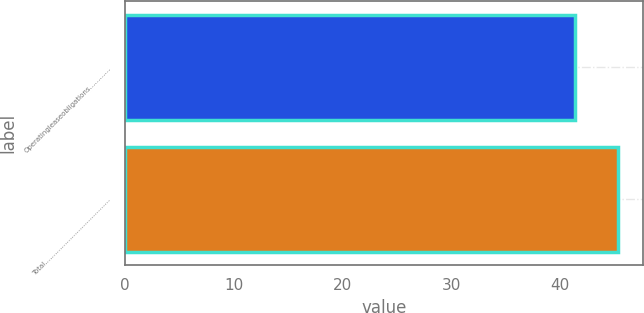Convert chart. <chart><loc_0><loc_0><loc_500><loc_500><bar_chart><fcel>Operatingleaseobligations…………<fcel>Total…………………………………<nl><fcel>41.4<fcel>45.4<nl></chart> 